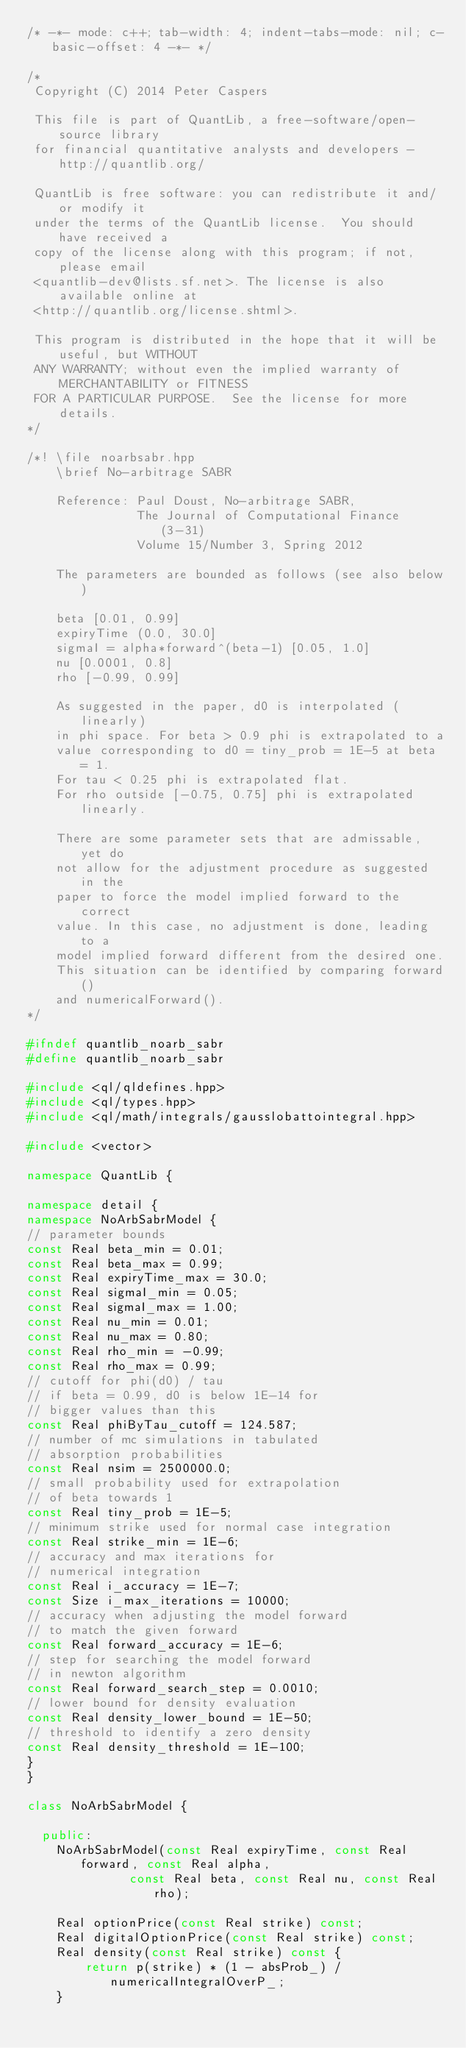Convert code to text. <code><loc_0><loc_0><loc_500><loc_500><_C++_>/* -*- mode: c++; tab-width: 4; indent-tabs-mode: nil; c-basic-offset: 4 -*- */

/*
 Copyright (C) 2014 Peter Caspers

 This file is part of QuantLib, a free-software/open-source library
 for financial quantitative analysts and developers - http://quantlib.org/

 QuantLib is free software: you can redistribute it and/or modify it
 under the terms of the QuantLib license.  You should have received a
 copy of the license along with this program; if not, please email
 <quantlib-dev@lists.sf.net>. The license is also available online at
 <http://quantlib.org/license.shtml>.

 This program is distributed in the hope that it will be useful, but WITHOUT
 ANY WARRANTY; without even the implied warranty of MERCHANTABILITY or FITNESS
 FOR A PARTICULAR PURPOSE.  See the license for more details.
*/

/*! \file noarbsabr.hpp
    \brief No-arbitrage SABR

    Reference: Paul Doust, No-arbitrage SABR,
               The Journal of Computational Finance (3-31)
               Volume 15/Number 3, Spring 2012

    The parameters are bounded as follows (see also below)

    beta [0.01, 0.99]
    expiryTime (0.0, 30.0]
    sigmaI = alpha*forward^(beta-1) [0.05, 1.0]
    nu [0.0001, 0.8]
    rho [-0.99, 0.99]

    As suggested in the paper, d0 is interpolated (linearly)
    in phi space. For beta > 0.9 phi is extrapolated to a
    value corresponding to d0 = tiny_prob = 1E-5 at beta = 1.
    For tau < 0.25 phi is extrapolated flat.
    For rho outside [-0.75, 0.75] phi is extrapolated linearly.

    There are some parameter sets that are admissable, yet do
    not allow for the adjustment procedure as suggested in the
    paper to force the model implied forward to the correct
    value. In this case, no adjustment is done, leading to a
    model implied forward different from the desired one.
    This situation can be identified by comparing forward()
    and numericalForward().
*/

#ifndef quantlib_noarb_sabr
#define quantlib_noarb_sabr

#include <ql/qldefines.hpp>
#include <ql/types.hpp>
#include <ql/math/integrals/gausslobattointegral.hpp>

#include <vector>

namespace QuantLib {

namespace detail {
namespace NoArbSabrModel {
// parameter bounds
const Real beta_min = 0.01;
const Real beta_max = 0.99;
const Real expiryTime_max = 30.0;
const Real sigmaI_min = 0.05;
const Real sigmaI_max = 1.00;
const Real nu_min = 0.01;
const Real nu_max = 0.80;
const Real rho_min = -0.99;
const Real rho_max = 0.99;
// cutoff for phi(d0) / tau
// if beta = 0.99, d0 is below 1E-14 for
// bigger values than this
const Real phiByTau_cutoff = 124.587;
// number of mc simulations in tabulated
// absorption probabilities
const Real nsim = 2500000.0;
// small probability used for extrapolation
// of beta towards 1
const Real tiny_prob = 1E-5;
// minimum strike used for normal case integration
const Real strike_min = 1E-6;
// accuracy and max iterations for
// numerical integration
const Real i_accuracy = 1E-7;
const Size i_max_iterations = 10000;
// accuracy when adjusting the model forward
// to match the given forward
const Real forward_accuracy = 1E-6;
// step for searching the model forward
// in newton algorithm
const Real forward_search_step = 0.0010;
// lower bound for density evaluation
const Real density_lower_bound = 1E-50;
// threshold to identify a zero density
const Real density_threshold = 1E-100;
}
}

class NoArbSabrModel {

  public:
    NoArbSabrModel(const Real expiryTime, const Real forward, const Real alpha,
              const Real beta, const Real nu, const Real rho);

    Real optionPrice(const Real strike) const;
    Real digitalOptionPrice(const Real strike) const;
    Real density(const Real strike) const {
        return p(strike) * (1 - absProb_) / numericalIntegralOverP_;
    }
</code> 